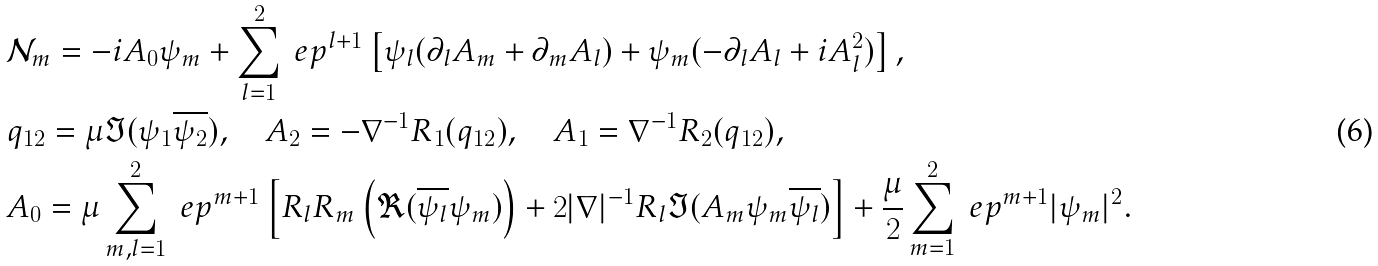Convert formula to latex. <formula><loc_0><loc_0><loc_500><loc_500>& \mathcal { N } _ { m } = - i A _ { 0 } \psi _ { m } + \sum _ { l = 1 } ^ { 2 } \ e p ^ { l + 1 } \left [ \psi _ { l } ( \partial _ { l } A _ { m } + \partial _ { m } A _ { l } ) + \psi _ { m } ( - \partial _ { l } A _ { l } + i A _ { l } ^ { 2 } ) \right ] , \\ & q _ { 1 2 } = \mu \Im ( \psi _ { 1 } \overline { \psi _ { 2 } } ) , \quad A _ { 2 } = - \nabla ^ { - 1 } R _ { 1 } ( q _ { 1 2 } ) , \quad A _ { 1 } = \nabla ^ { - 1 } R _ { 2 } ( q _ { 1 2 } ) , \\ & A _ { 0 } = \mu \sum _ { m , l = 1 } ^ { 2 } \ e p ^ { m + 1 } \left [ R _ { l } R _ { m } \left ( \Re ( \overline { \psi _ { l } } \psi _ { m } ) \right ) + 2 | \nabla | ^ { - 1 } R _ { l } \Im ( A _ { m } \psi _ { m } \overline { \psi _ { l } } ) \right ] + \frac { \mu } { 2 } \sum _ { m = 1 } ^ { 2 } \ e p ^ { m + 1 } | \psi _ { m } | ^ { 2 } .</formula> 